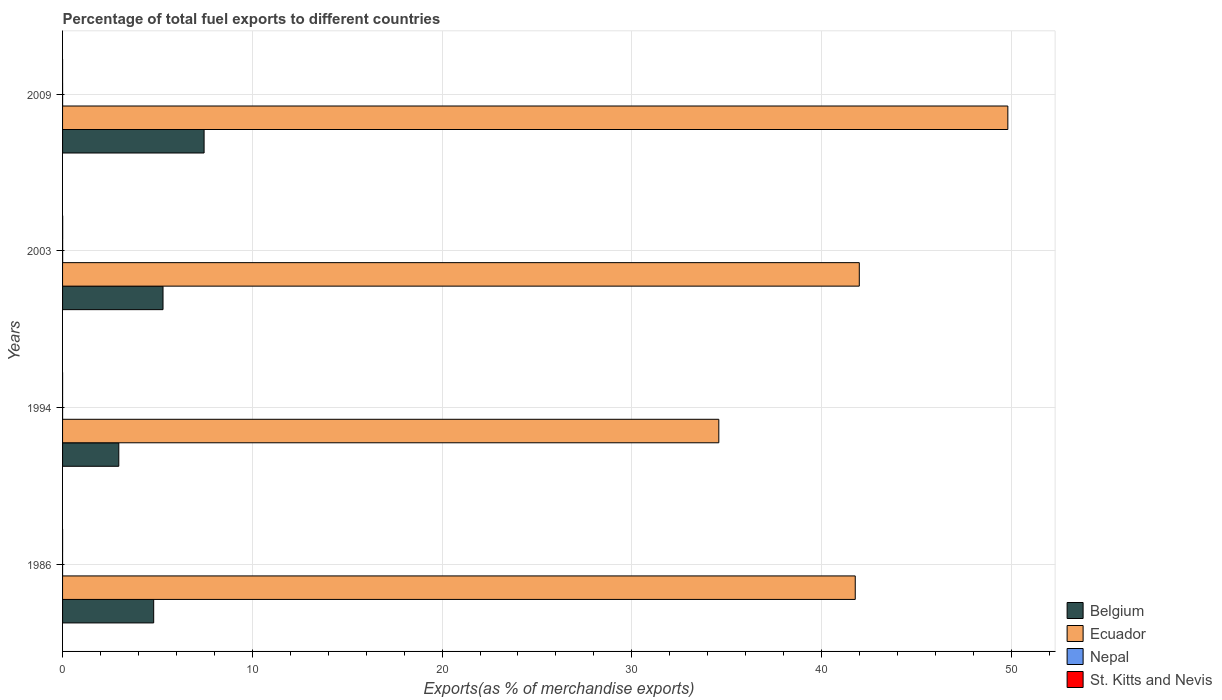How many different coloured bars are there?
Keep it short and to the point. 4. How many groups of bars are there?
Provide a succinct answer. 4. Are the number of bars per tick equal to the number of legend labels?
Your answer should be very brief. Yes. How many bars are there on the 4th tick from the top?
Your answer should be very brief. 4. How many bars are there on the 3rd tick from the bottom?
Offer a very short reply. 4. In how many cases, is the number of bars for a given year not equal to the number of legend labels?
Give a very brief answer. 0. What is the percentage of exports to different countries in Nepal in 2009?
Your response must be concise. 0. Across all years, what is the maximum percentage of exports to different countries in Nepal?
Your answer should be very brief. 0. Across all years, what is the minimum percentage of exports to different countries in Belgium?
Offer a very short reply. 2.96. In which year was the percentage of exports to different countries in Belgium minimum?
Give a very brief answer. 1994. What is the total percentage of exports to different countries in Nepal in the graph?
Offer a very short reply. 0.01. What is the difference between the percentage of exports to different countries in Nepal in 1994 and that in 2003?
Give a very brief answer. -0. What is the difference between the percentage of exports to different countries in Belgium in 2009 and the percentage of exports to different countries in St. Kitts and Nevis in 1986?
Your answer should be compact. 7.46. What is the average percentage of exports to different countries in Nepal per year?
Your response must be concise. 0. In the year 2009, what is the difference between the percentage of exports to different countries in St. Kitts and Nevis and percentage of exports to different countries in Nepal?
Provide a succinct answer. -0. In how many years, is the percentage of exports to different countries in Nepal greater than 16 %?
Provide a succinct answer. 0. What is the ratio of the percentage of exports to different countries in Belgium in 1986 to that in 2009?
Offer a terse response. 0.64. Is the percentage of exports to different countries in Nepal in 1994 less than that in 2009?
Make the answer very short. Yes. What is the difference between the highest and the second highest percentage of exports to different countries in Nepal?
Provide a succinct answer. 0. What is the difference between the highest and the lowest percentage of exports to different countries in Nepal?
Keep it short and to the point. 0. Is the sum of the percentage of exports to different countries in St. Kitts and Nevis in 1994 and 2003 greater than the maximum percentage of exports to different countries in Ecuador across all years?
Make the answer very short. No. What does the 3rd bar from the top in 1986 represents?
Offer a terse response. Ecuador. What does the 3rd bar from the bottom in 2009 represents?
Provide a short and direct response. Nepal. How many bars are there?
Provide a short and direct response. 16. How many years are there in the graph?
Your answer should be very brief. 4. What is the difference between two consecutive major ticks on the X-axis?
Your answer should be compact. 10. Where does the legend appear in the graph?
Offer a terse response. Bottom right. How are the legend labels stacked?
Your response must be concise. Vertical. What is the title of the graph?
Your answer should be very brief. Percentage of total fuel exports to different countries. Does "High income: OECD" appear as one of the legend labels in the graph?
Your response must be concise. No. What is the label or title of the X-axis?
Your response must be concise. Exports(as % of merchandise exports). What is the Exports(as % of merchandise exports) in Belgium in 1986?
Offer a terse response. 4.8. What is the Exports(as % of merchandise exports) of Ecuador in 1986?
Keep it short and to the point. 41.77. What is the Exports(as % of merchandise exports) of Nepal in 1986?
Keep it short and to the point. 3.330786435512e-5. What is the Exports(as % of merchandise exports) of St. Kitts and Nevis in 1986?
Provide a succinct answer. 0. What is the Exports(as % of merchandise exports) in Belgium in 1994?
Your answer should be very brief. 2.96. What is the Exports(as % of merchandise exports) in Ecuador in 1994?
Keep it short and to the point. 34.58. What is the Exports(as % of merchandise exports) in Nepal in 1994?
Provide a short and direct response. 0. What is the Exports(as % of merchandise exports) of St. Kitts and Nevis in 1994?
Offer a terse response. 0. What is the Exports(as % of merchandise exports) in Belgium in 2003?
Your answer should be very brief. 5.29. What is the Exports(as % of merchandise exports) of Ecuador in 2003?
Ensure brevity in your answer.  41.99. What is the Exports(as % of merchandise exports) of Nepal in 2003?
Provide a short and direct response. 0. What is the Exports(as % of merchandise exports) of St. Kitts and Nevis in 2003?
Provide a succinct answer. 0.01. What is the Exports(as % of merchandise exports) in Belgium in 2009?
Your answer should be compact. 7.46. What is the Exports(as % of merchandise exports) of Ecuador in 2009?
Keep it short and to the point. 49.82. What is the Exports(as % of merchandise exports) of Nepal in 2009?
Ensure brevity in your answer.  0. What is the Exports(as % of merchandise exports) in St. Kitts and Nevis in 2009?
Offer a terse response. 0. Across all years, what is the maximum Exports(as % of merchandise exports) of Belgium?
Give a very brief answer. 7.46. Across all years, what is the maximum Exports(as % of merchandise exports) of Ecuador?
Provide a short and direct response. 49.82. Across all years, what is the maximum Exports(as % of merchandise exports) in Nepal?
Provide a succinct answer. 0. Across all years, what is the maximum Exports(as % of merchandise exports) of St. Kitts and Nevis?
Provide a succinct answer. 0.01. Across all years, what is the minimum Exports(as % of merchandise exports) in Belgium?
Offer a very short reply. 2.96. Across all years, what is the minimum Exports(as % of merchandise exports) of Ecuador?
Your response must be concise. 34.58. Across all years, what is the minimum Exports(as % of merchandise exports) of Nepal?
Provide a succinct answer. 3.330786435512e-5. Across all years, what is the minimum Exports(as % of merchandise exports) of St. Kitts and Nevis?
Make the answer very short. 0. What is the total Exports(as % of merchandise exports) of Belgium in the graph?
Give a very brief answer. 20.52. What is the total Exports(as % of merchandise exports) in Ecuador in the graph?
Give a very brief answer. 168.16. What is the total Exports(as % of merchandise exports) in Nepal in the graph?
Your answer should be compact. 0.01. What is the total Exports(as % of merchandise exports) of St. Kitts and Nevis in the graph?
Give a very brief answer. 0.01. What is the difference between the Exports(as % of merchandise exports) in Belgium in 1986 and that in 1994?
Your answer should be compact. 1.84. What is the difference between the Exports(as % of merchandise exports) in Ecuador in 1986 and that in 1994?
Ensure brevity in your answer.  7.19. What is the difference between the Exports(as % of merchandise exports) in Nepal in 1986 and that in 1994?
Offer a very short reply. -0. What is the difference between the Exports(as % of merchandise exports) of St. Kitts and Nevis in 1986 and that in 1994?
Your answer should be very brief. -0. What is the difference between the Exports(as % of merchandise exports) of Belgium in 1986 and that in 2003?
Ensure brevity in your answer.  -0.49. What is the difference between the Exports(as % of merchandise exports) in Ecuador in 1986 and that in 2003?
Make the answer very short. -0.21. What is the difference between the Exports(as % of merchandise exports) of Nepal in 1986 and that in 2003?
Make the answer very short. -0. What is the difference between the Exports(as % of merchandise exports) of St. Kitts and Nevis in 1986 and that in 2003?
Offer a terse response. -0.01. What is the difference between the Exports(as % of merchandise exports) in Belgium in 1986 and that in 2009?
Your response must be concise. -2.66. What is the difference between the Exports(as % of merchandise exports) of Ecuador in 1986 and that in 2009?
Keep it short and to the point. -8.04. What is the difference between the Exports(as % of merchandise exports) in Nepal in 1986 and that in 2009?
Your response must be concise. -0. What is the difference between the Exports(as % of merchandise exports) of St. Kitts and Nevis in 1986 and that in 2009?
Offer a terse response. 0. What is the difference between the Exports(as % of merchandise exports) of Belgium in 1994 and that in 2003?
Your answer should be compact. -2.33. What is the difference between the Exports(as % of merchandise exports) in Ecuador in 1994 and that in 2003?
Your answer should be very brief. -7.4. What is the difference between the Exports(as % of merchandise exports) of Nepal in 1994 and that in 2003?
Provide a short and direct response. -0. What is the difference between the Exports(as % of merchandise exports) of St. Kitts and Nevis in 1994 and that in 2003?
Your answer should be very brief. -0.01. What is the difference between the Exports(as % of merchandise exports) of Belgium in 1994 and that in 2009?
Your answer should be compact. -4.5. What is the difference between the Exports(as % of merchandise exports) of Ecuador in 1994 and that in 2009?
Your answer should be compact. -15.23. What is the difference between the Exports(as % of merchandise exports) in Nepal in 1994 and that in 2009?
Provide a succinct answer. -0. What is the difference between the Exports(as % of merchandise exports) in St. Kitts and Nevis in 1994 and that in 2009?
Offer a terse response. 0. What is the difference between the Exports(as % of merchandise exports) of Belgium in 2003 and that in 2009?
Offer a terse response. -2.16. What is the difference between the Exports(as % of merchandise exports) in Ecuador in 2003 and that in 2009?
Give a very brief answer. -7.83. What is the difference between the Exports(as % of merchandise exports) in Nepal in 2003 and that in 2009?
Make the answer very short. 0. What is the difference between the Exports(as % of merchandise exports) in St. Kitts and Nevis in 2003 and that in 2009?
Provide a succinct answer. 0.01. What is the difference between the Exports(as % of merchandise exports) in Belgium in 1986 and the Exports(as % of merchandise exports) in Ecuador in 1994?
Provide a succinct answer. -29.78. What is the difference between the Exports(as % of merchandise exports) in Belgium in 1986 and the Exports(as % of merchandise exports) in Nepal in 1994?
Give a very brief answer. 4.8. What is the difference between the Exports(as % of merchandise exports) of Belgium in 1986 and the Exports(as % of merchandise exports) of St. Kitts and Nevis in 1994?
Offer a terse response. 4.8. What is the difference between the Exports(as % of merchandise exports) of Ecuador in 1986 and the Exports(as % of merchandise exports) of Nepal in 1994?
Provide a short and direct response. 41.77. What is the difference between the Exports(as % of merchandise exports) in Ecuador in 1986 and the Exports(as % of merchandise exports) in St. Kitts and Nevis in 1994?
Provide a short and direct response. 41.77. What is the difference between the Exports(as % of merchandise exports) in Nepal in 1986 and the Exports(as % of merchandise exports) in St. Kitts and Nevis in 1994?
Ensure brevity in your answer.  -0. What is the difference between the Exports(as % of merchandise exports) of Belgium in 1986 and the Exports(as % of merchandise exports) of Ecuador in 2003?
Your response must be concise. -37.19. What is the difference between the Exports(as % of merchandise exports) of Belgium in 1986 and the Exports(as % of merchandise exports) of Nepal in 2003?
Keep it short and to the point. 4.8. What is the difference between the Exports(as % of merchandise exports) of Belgium in 1986 and the Exports(as % of merchandise exports) of St. Kitts and Nevis in 2003?
Provide a succinct answer. 4.8. What is the difference between the Exports(as % of merchandise exports) in Ecuador in 1986 and the Exports(as % of merchandise exports) in Nepal in 2003?
Your answer should be compact. 41.77. What is the difference between the Exports(as % of merchandise exports) of Ecuador in 1986 and the Exports(as % of merchandise exports) of St. Kitts and Nevis in 2003?
Your response must be concise. 41.77. What is the difference between the Exports(as % of merchandise exports) in Nepal in 1986 and the Exports(as % of merchandise exports) in St. Kitts and Nevis in 2003?
Your response must be concise. -0.01. What is the difference between the Exports(as % of merchandise exports) in Belgium in 1986 and the Exports(as % of merchandise exports) in Ecuador in 2009?
Your response must be concise. -45.01. What is the difference between the Exports(as % of merchandise exports) of Belgium in 1986 and the Exports(as % of merchandise exports) of Nepal in 2009?
Offer a terse response. 4.8. What is the difference between the Exports(as % of merchandise exports) in Belgium in 1986 and the Exports(as % of merchandise exports) in St. Kitts and Nevis in 2009?
Offer a very short reply. 4.8. What is the difference between the Exports(as % of merchandise exports) in Ecuador in 1986 and the Exports(as % of merchandise exports) in Nepal in 2009?
Ensure brevity in your answer.  41.77. What is the difference between the Exports(as % of merchandise exports) in Ecuador in 1986 and the Exports(as % of merchandise exports) in St. Kitts and Nevis in 2009?
Offer a very short reply. 41.77. What is the difference between the Exports(as % of merchandise exports) of Nepal in 1986 and the Exports(as % of merchandise exports) of St. Kitts and Nevis in 2009?
Provide a short and direct response. -0. What is the difference between the Exports(as % of merchandise exports) in Belgium in 1994 and the Exports(as % of merchandise exports) in Ecuador in 2003?
Provide a succinct answer. -39.02. What is the difference between the Exports(as % of merchandise exports) in Belgium in 1994 and the Exports(as % of merchandise exports) in Nepal in 2003?
Offer a very short reply. 2.96. What is the difference between the Exports(as % of merchandise exports) in Belgium in 1994 and the Exports(as % of merchandise exports) in St. Kitts and Nevis in 2003?
Offer a very short reply. 2.96. What is the difference between the Exports(as % of merchandise exports) in Ecuador in 1994 and the Exports(as % of merchandise exports) in Nepal in 2003?
Your answer should be compact. 34.58. What is the difference between the Exports(as % of merchandise exports) in Ecuador in 1994 and the Exports(as % of merchandise exports) in St. Kitts and Nevis in 2003?
Offer a terse response. 34.58. What is the difference between the Exports(as % of merchandise exports) of Nepal in 1994 and the Exports(as % of merchandise exports) of St. Kitts and Nevis in 2003?
Provide a succinct answer. -0.01. What is the difference between the Exports(as % of merchandise exports) in Belgium in 1994 and the Exports(as % of merchandise exports) in Ecuador in 2009?
Ensure brevity in your answer.  -46.85. What is the difference between the Exports(as % of merchandise exports) in Belgium in 1994 and the Exports(as % of merchandise exports) in Nepal in 2009?
Your answer should be very brief. 2.96. What is the difference between the Exports(as % of merchandise exports) in Belgium in 1994 and the Exports(as % of merchandise exports) in St. Kitts and Nevis in 2009?
Provide a short and direct response. 2.96. What is the difference between the Exports(as % of merchandise exports) of Ecuador in 1994 and the Exports(as % of merchandise exports) of Nepal in 2009?
Your response must be concise. 34.58. What is the difference between the Exports(as % of merchandise exports) in Ecuador in 1994 and the Exports(as % of merchandise exports) in St. Kitts and Nevis in 2009?
Provide a succinct answer. 34.58. What is the difference between the Exports(as % of merchandise exports) in Belgium in 2003 and the Exports(as % of merchandise exports) in Ecuador in 2009?
Give a very brief answer. -44.52. What is the difference between the Exports(as % of merchandise exports) in Belgium in 2003 and the Exports(as % of merchandise exports) in Nepal in 2009?
Offer a terse response. 5.29. What is the difference between the Exports(as % of merchandise exports) in Belgium in 2003 and the Exports(as % of merchandise exports) in St. Kitts and Nevis in 2009?
Your answer should be very brief. 5.29. What is the difference between the Exports(as % of merchandise exports) in Ecuador in 2003 and the Exports(as % of merchandise exports) in Nepal in 2009?
Keep it short and to the point. 41.99. What is the difference between the Exports(as % of merchandise exports) of Ecuador in 2003 and the Exports(as % of merchandise exports) of St. Kitts and Nevis in 2009?
Offer a terse response. 41.99. What is the difference between the Exports(as % of merchandise exports) of Nepal in 2003 and the Exports(as % of merchandise exports) of St. Kitts and Nevis in 2009?
Provide a short and direct response. 0. What is the average Exports(as % of merchandise exports) of Belgium per year?
Offer a terse response. 5.13. What is the average Exports(as % of merchandise exports) of Ecuador per year?
Your response must be concise. 42.04. What is the average Exports(as % of merchandise exports) in Nepal per year?
Provide a short and direct response. 0. What is the average Exports(as % of merchandise exports) in St. Kitts and Nevis per year?
Make the answer very short. 0. In the year 1986, what is the difference between the Exports(as % of merchandise exports) in Belgium and Exports(as % of merchandise exports) in Ecuador?
Give a very brief answer. -36.97. In the year 1986, what is the difference between the Exports(as % of merchandise exports) in Belgium and Exports(as % of merchandise exports) in Nepal?
Provide a short and direct response. 4.8. In the year 1986, what is the difference between the Exports(as % of merchandise exports) of Belgium and Exports(as % of merchandise exports) of St. Kitts and Nevis?
Your response must be concise. 4.8. In the year 1986, what is the difference between the Exports(as % of merchandise exports) in Ecuador and Exports(as % of merchandise exports) in Nepal?
Offer a very short reply. 41.77. In the year 1986, what is the difference between the Exports(as % of merchandise exports) in Ecuador and Exports(as % of merchandise exports) in St. Kitts and Nevis?
Keep it short and to the point. 41.77. In the year 1986, what is the difference between the Exports(as % of merchandise exports) in Nepal and Exports(as % of merchandise exports) in St. Kitts and Nevis?
Your response must be concise. -0. In the year 1994, what is the difference between the Exports(as % of merchandise exports) of Belgium and Exports(as % of merchandise exports) of Ecuador?
Offer a terse response. -31.62. In the year 1994, what is the difference between the Exports(as % of merchandise exports) in Belgium and Exports(as % of merchandise exports) in Nepal?
Offer a terse response. 2.96. In the year 1994, what is the difference between the Exports(as % of merchandise exports) of Belgium and Exports(as % of merchandise exports) of St. Kitts and Nevis?
Make the answer very short. 2.96. In the year 1994, what is the difference between the Exports(as % of merchandise exports) in Ecuador and Exports(as % of merchandise exports) in Nepal?
Give a very brief answer. 34.58. In the year 1994, what is the difference between the Exports(as % of merchandise exports) in Ecuador and Exports(as % of merchandise exports) in St. Kitts and Nevis?
Your answer should be compact. 34.58. In the year 1994, what is the difference between the Exports(as % of merchandise exports) in Nepal and Exports(as % of merchandise exports) in St. Kitts and Nevis?
Your response must be concise. -0. In the year 2003, what is the difference between the Exports(as % of merchandise exports) of Belgium and Exports(as % of merchandise exports) of Ecuador?
Make the answer very short. -36.69. In the year 2003, what is the difference between the Exports(as % of merchandise exports) in Belgium and Exports(as % of merchandise exports) in Nepal?
Provide a short and direct response. 5.29. In the year 2003, what is the difference between the Exports(as % of merchandise exports) in Belgium and Exports(as % of merchandise exports) in St. Kitts and Nevis?
Make the answer very short. 5.29. In the year 2003, what is the difference between the Exports(as % of merchandise exports) in Ecuador and Exports(as % of merchandise exports) in Nepal?
Make the answer very short. 41.98. In the year 2003, what is the difference between the Exports(as % of merchandise exports) of Ecuador and Exports(as % of merchandise exports) of St. Kitts and Nevis?
Your answer should be compact. 41.98. In the year 2003, what is the difference between the Exports(as % of merchandise exports) of Nepal and Exports(as % of merchandise exports) of St. Kitts and Nevis?
Provide a succinct answer. -0. In the year 2009, what is the difference between the Exports(as % of merchandise exports) in Belgium and Exports(as % of merchandise exports) in Ecuador?
Your answer should be compact. -42.36. In the year 2009, what is the difference between the Exports(as % of merchandise exports) in Belgium and Exports(as % of merchandise exports) in Nepal?
Make the answer very short. 7.46. In the year 2009, what is the difference between the Exports(as % of merchandise exports) of Belgium and Exports(as % of merchandise exports) of St. Kitts and Nevis?
Give a very brief answer. 7.46. In the year 2009, what is the difference between the Exports(as % of merchandise exports) in Ecuador and Exports(as % of merchandise exports) in Nepal?
Keep it short and to the point. 49.81. In the year 2009, what is the difference between the Exports(as % of merchandise exports) in Ecuador and Exports(as % of merchandise exports) in St. Kitts and Nevis?
Your response must be concise. 49.82. In the year 2009, what is the difference between the Exports(as % of merchandise exports) of Nepal and Exports(as % of merchandise exports) of St. Kitts and Nevis?
Your answer should be compact. 0. What is the ratio of the Exports(as % of merchandise exports) in Belgium in 1986 to that in 1994?
Provide a succinct answer. 1.62. What is the ratio of the Exports(as % of merchandise exports) of Ecuador in 1986 to that in 1994?
Your answer should be very brief. 1.21. What is the ratio of the Exports(as % of merchandise exports) in Nepal in 1986 to that in 1994?
Your response must be concise. 0.12. What is the ratio of the Exports(as % of merchandise exports) in St. Kitts and Nevis in 1986 to that in 1994?
Make the answer very short. 0.82. What is the ratio of the Exports(as % of merchandise exports) in Belgium in 1986 to that in 2003?
Your answer should be very brief. 0.91. What is the ratio of the Exports(as % of merchandise exports) of Nepal in 1986 to that in 2003?
Offer a very short reply. 0.01. What is the ratio of the Exports(as % of merchandise exports) in St. Kitts and Nevis in 1986 to that in 2003?
Offer a very short reply. 0.06. What is the ratio of the Exports(as % of merchandise exports) of Belgium in 1986 to that in 2009?
Keep it short and to the point. 0.64. What is the ratio of the Exports(as % of merchandise exports) of Ecuador in 1986 to that in 2009?
Your response must be concise. 0.84. What is the ratio of the Exports(as % of merchandise exports) in Nepal in 1986 to that in 2009?
Give a very brief answer. 0.02. What is the ratio of the Exports(as % of merchandise exports) in St. Kitts and Nevis in 1986 to that in 2009?
Provide a succinct answer. 3.46. What is the ratio of the Exports(as % of merchandise exports) of Belgium in 1994 to that in 2003?
Give a very brief answer. 0.56. What is the ratio of the Exports(as % of merchandise exports) of Ecuador in 1994 to that in 2003?
Keep it short and to the point. 0.82. What is the ratio of the Exports(as % of merchandise exports) in Nepal in 1994 to that in 2003?
Make the answer very short. 0.08. What is the ratio of the Exports(as % of merchandise exports) in St. Kitts and Nevis in 1994 to that in 2003?
Provide a short and direct response. 0.08. What is the ratio of the Exports(as % of merchandise exports) of Belgium in 1994 to that in 2009?
Your response must be concise. 0.4. What is the ratio of the Exports(as % of merchandise exports) of Ecuador in 1994 to that in 2009?
Provide a succinct answer. 0.69. What is the ratio of the Exports(as % of merchandise exports) of Nepal in 1994 to that in 2009?
Provide a succinct answer. 0.16. What is the ratio of the Exports(as % of merchandise exports) in St. Kitts and Nevis in 1994 to that in 2009?
Keep it short and to the point. 4.23. What is the ratio of the Exports(as % of merchandise exports) of Belgium in 2003 to that in 2009?
Ensure brevity in your answer.  0.71. What is the ratio of the Exports(as % of merchandise exports) in Ecuador in 2003 to that in 2009?
Your response must be concise. 0.84. What is the ratio of the Exports(as % of merchandise exports) of Nepal in 2003 to that in 2009?
Your answer should be very brief. 2.12. What is the ratio of the Exports(as % of merchandise exports) of St. Kitts and Nevis in 2003 to that in 2009?
Keep it short and to the point. 56.07. What is the difference between the highest and the second highest Exports(as % of merchandise exports) in Belgium?
Offer a terse response. 2.16. What is the difference between the highest and the second highest Exports(as % of merchandise exports) of Ecuador?
Offer a terse response. 7.83. What is the difference between the highest and the second highest Exports(as % of merchandise exports) in Nepal?
Provide a short and direct response. 0. What is the difference between the highest and the second highest Exports(as % of merchandise exports) of St. Kitts and Nevis?
Keep it short and to the point. 0.01. What is the difference between the highest and the lowest Exports(as % of merchandise exports) in Belgium?
Ensure brevity in your answer.  4.5. What is the difference between the highest and the lowest Exports(as % of merchandise exports) in Ecuador?
Give a very brief answer. 15.23. What is the difference between the highest and the lowest Exports(as % of merchandise exports) of Nepal?
Ensure brevity in your answer.  0. What is the difference between the highest and the lowest Exports(as % of merchandise exports) in St. Kitts and Nevis?
Your response must be concise. 0.01. 